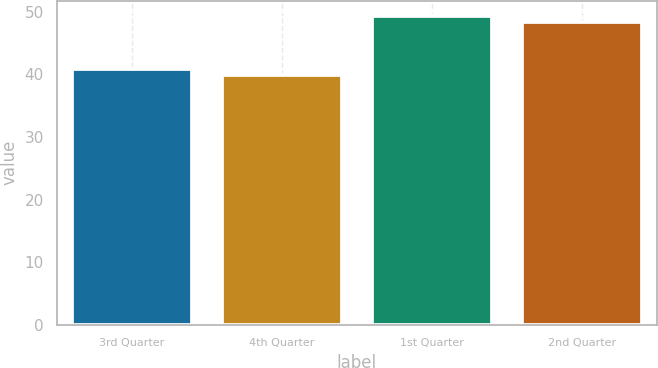Convert chart. <chart><loc_0><loc_0><loc_500><loc_500><bar_chart><fcel>3rd Quarter<fcel>4th Quarter<fcel>1st Quarter<fcel>2nd Quarter<nl><fcel>40.83<fcel>39.96<fcel>49.3<fcel>48.43<nl></chart> 